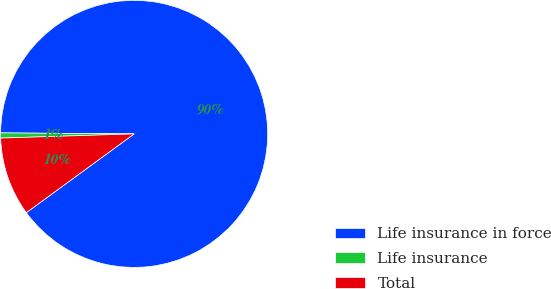<chart> <loc_0><loc_0><loc_500><loc_500><pie_chart><fcel>Life insurance in force<fcel>Life insurance<fcel>Total<nl><fcel>89.84%<fcel>0.62%<fcel>9.54%<nl></chart> 